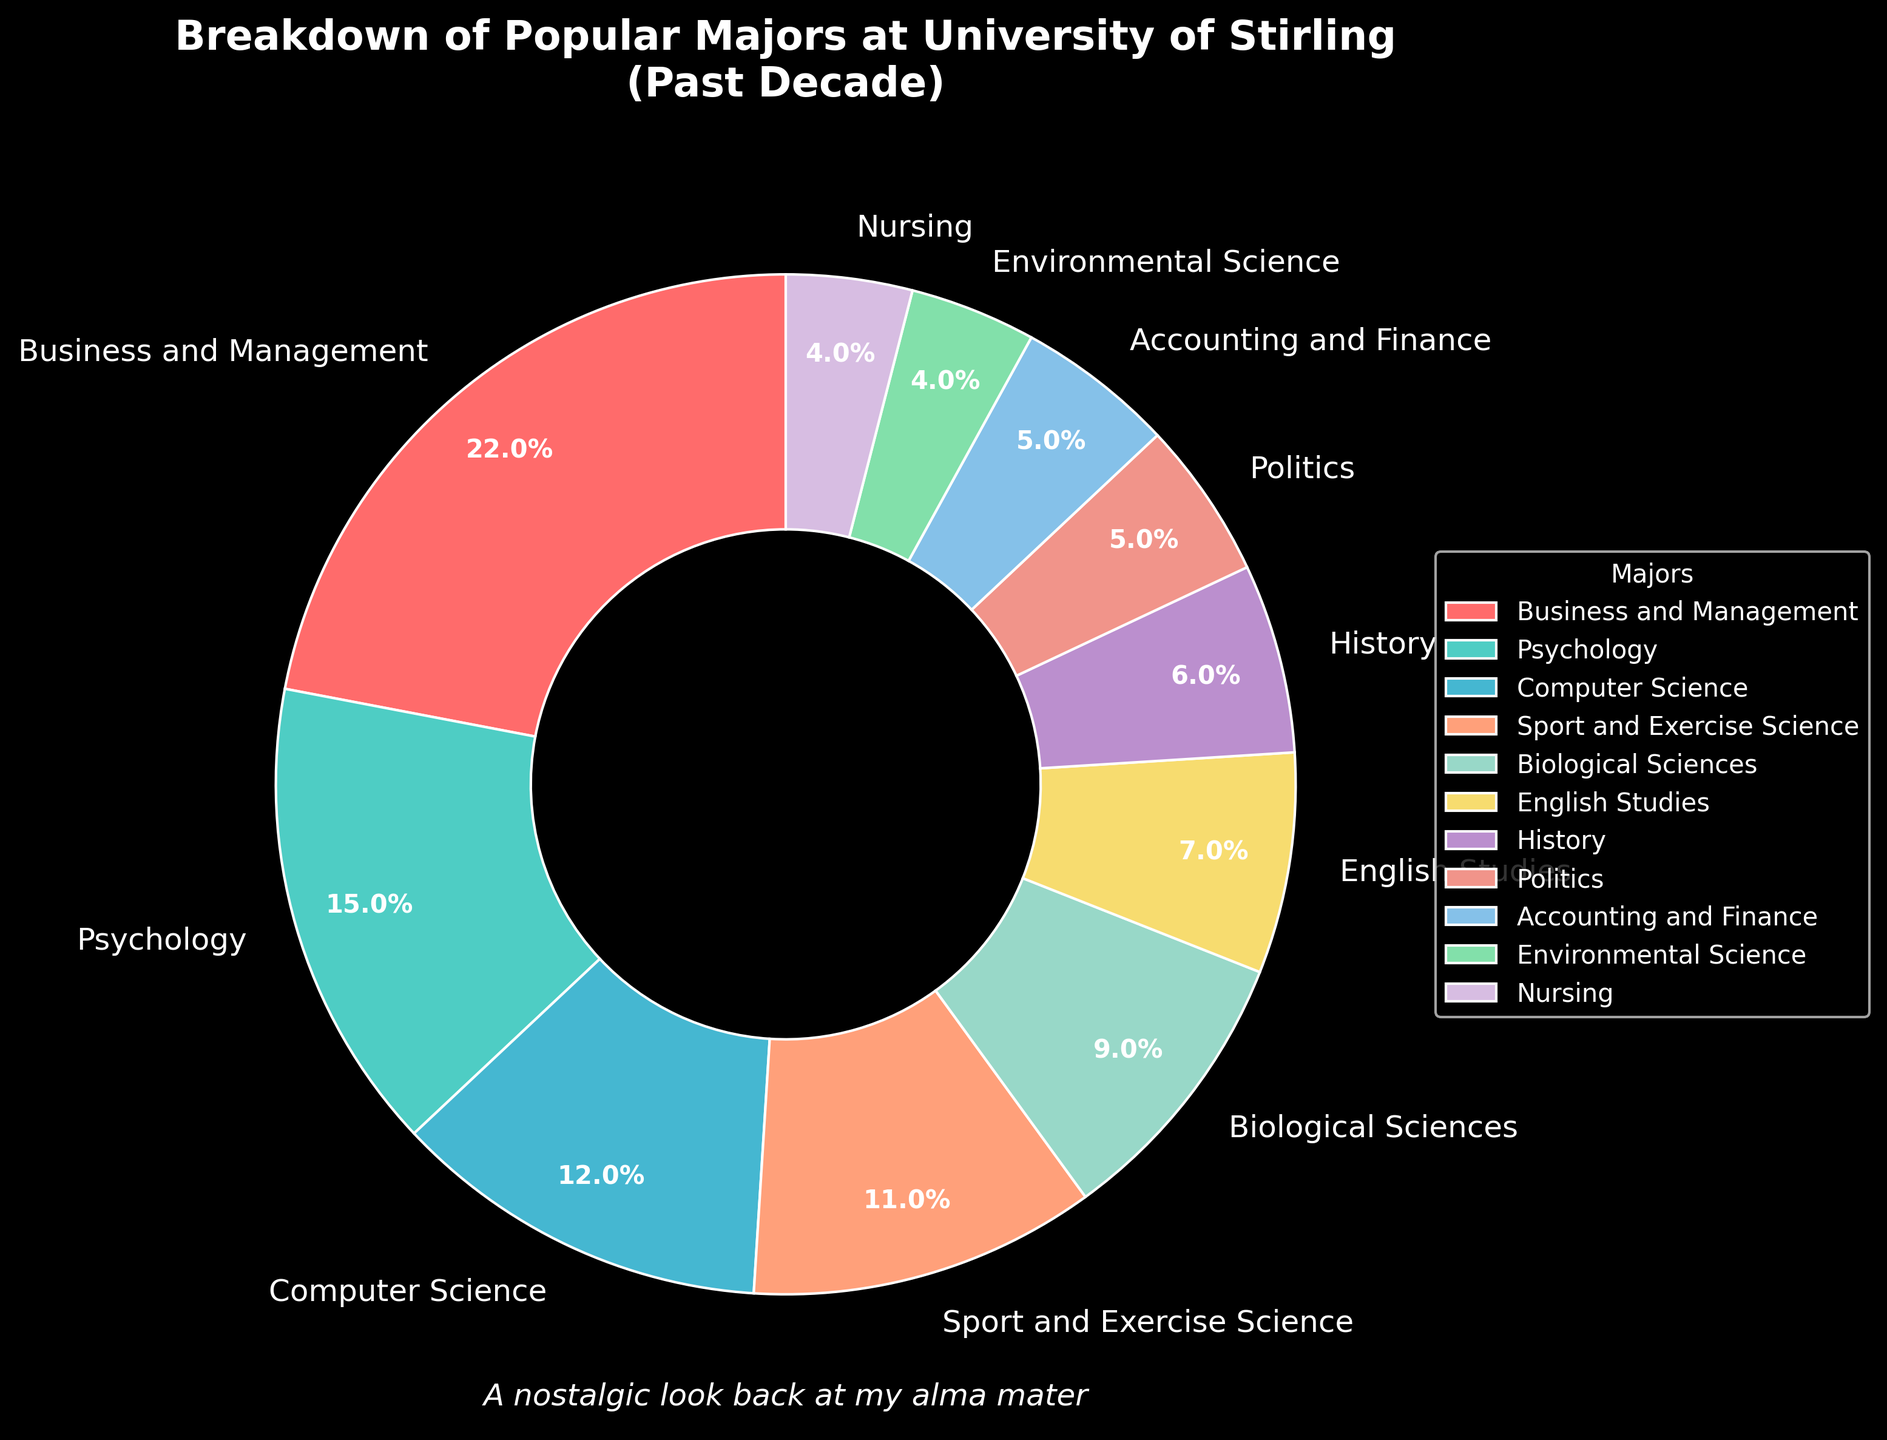What major has the highest percentage of students? The figure shows a pie chart with labels indicating the percentage of students in each major. Business and Management has the highest percentage at 22%.
Answer: Business and Management What is the combined percentage of students in Psychology and Computer Science? According to the figure, Psychology has 15% and Computer Science has 12%. Adding these percentages gives us 15% + 12% = 27%.
Answer: 27% Which major has a larger percentage of students, Sport and Exercise Science or Biological Sciences? The pie chart indicates that Sport and Exercise Science has 11% while Biological Sciences has 9%. Since 11% is greater than 9%, Sport and Exercise Science has a larger percentage.
Answer: Sport and Exercise Science What is the total percentage of students in majors that each have less than 10%? The majors with less than 10% are Biological Sciences (9%), English Studies (7%), History (6%), Politics (5%), Accounting and Finance (5%), Environmental Science (4%), and Nursing (4%). Adding these provides 9% + 7% + 6% + 5% + 5% + 4% + 4% = 40%.
Answer: 40% Which majors have exactly the same percentage of students? Examining the pie chart, we see that Politics and Accounting and Finance both have 5%. Furthermore, Environmental Science and Nursing both have 4%. There are two pairs of majors with the same percentages.
Answer: Politics and Accounting and Finance; Environmental Science and Nursing What is the difference in the percentage of students between Business and Management and Nursing? Business and Management has 22% while Nursing has 4%. The difference is 22% - 4% = 18%.
Answer: 18% List the majors in order of decreasing percentage. Based on the pie chart: Business and Management (22%), Psychology (15%), Computer Science (12%), Sport and Exercise Science (11%), Biological Sciences (9%), English Studies (7%), History (6%), Politics (5%), Accounting and Finance (5%), Environmental Science (4%), and Nursing (4%).
Answer: Business and Management, Psychology, Computer Science, Sport and Exercise Science, Biological Sciences, English Studies, History, Politics, Accounting and Finance, Environmental Science, Nursing Which major is represented by the red color on the pie chart? The pie chart uses red for Business and Management, as specified in the colors array in the code.
Answer: Business and Management What percent of students chose majors in the sciences (sum of Computer Science, Sport and Exercise Science, Biological Sciences, and Environmental Science)? Adding the percentages for computer-related and science majors: Computer Science (12%), Sport and Exercise Science (11%), Biological Sciences (9%), and Environmental Science (4%) gives 12% + 11% + 9% + 4% = 36%.
Answer: 36% 